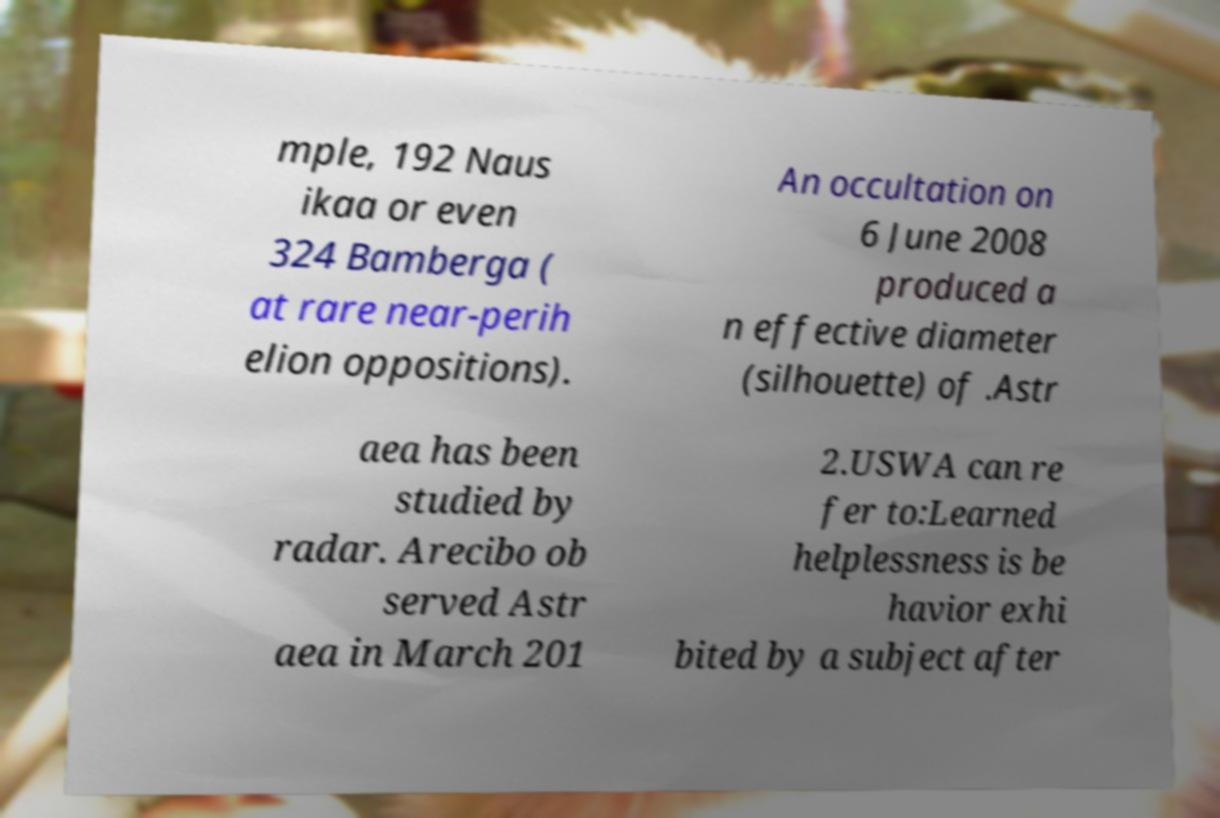Please read and relay the text visible in this image. What does it say? mple, 192 Naus ikaa or even 324 Bamberga ( at rare near-perih elion oppositions). An occultation on 6 June 2008 produced a n effective diameter (silhouette) of .Astr aea has been studied by radar. Arecibo ob served Astr aea in March 201 2.USWA can re fer to:Learned helplessness is be havior exhi bited by a subject after 